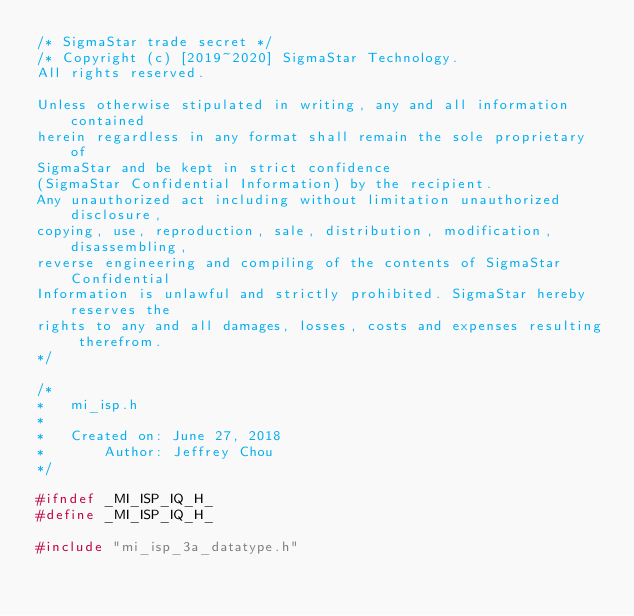<code> <loc_0><loc_0><loc_500><loc_500><_C_>/* SigmaStar trade secret */
/* Copyright (c) [2019~2020] SigmaStar Technology.
All rights reserved.

Unless otherwise stipulated in writing, any and all information contained
herein regardless in any format shall remain the sole proprietary of
SigmaStar and be kept in strict confidence
(SigmaStar Confidential Information) by the recipient.
Any unauthorized act including without limitation unauthorized disclosure,
copying, use, reproduction, sale, distribution, modification, disassembling,
reverse engineering and compiling of the contents of SigmaStar Confidential
Information is unlawful and strictly prohibited. SigmaStar hereby reserves the
rights to any and all damages, losses, costs and expenses resulting therefrom.
*/

/*
*   mi_isp.h
*
*   Created on: June 27, 2018
*       Author: Jeffrey Chou
*/

#ifndef _MI_ISP_IQ_H_
#define _MI_ISP_IQ_H_

#include "mi_isp_3a_datatype.h"</code> 